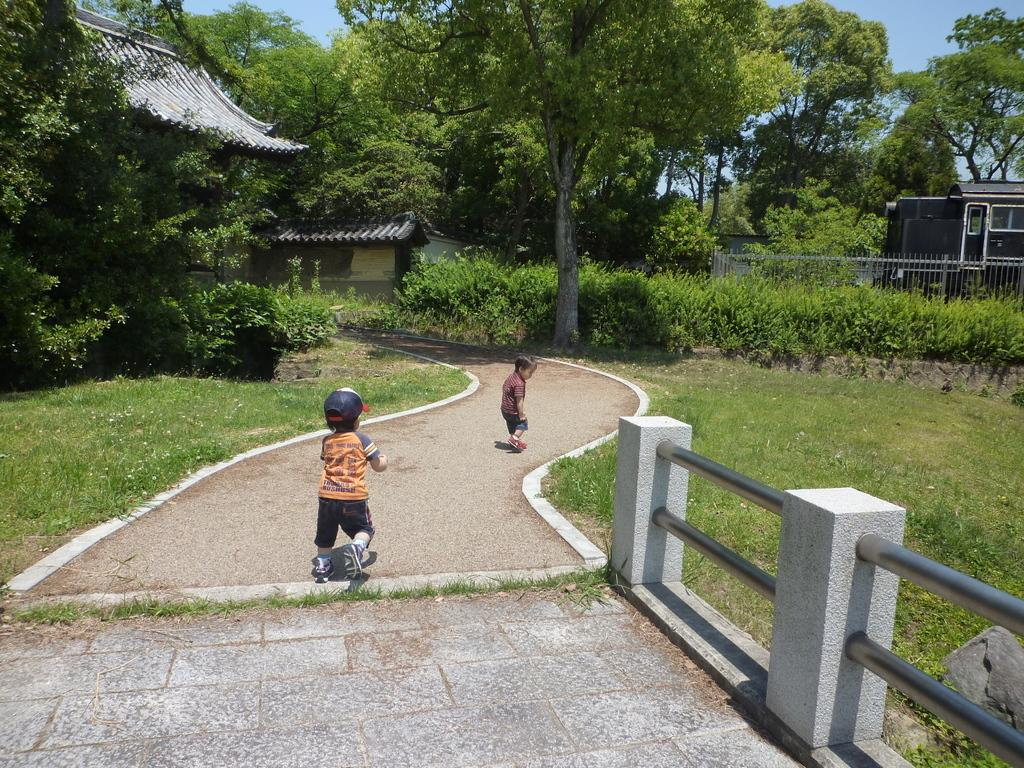How many kids are in the image? There are two kids in the image. What type of surface are the kids standing on? There is grass in the image, which is likely the surface they are standing on. What is the purpose of the fence in the image? The purpose of the fence is not explicitly stated, but it may be used to define boundaries or provide safety. What can be seen in the background of the image? In the background of the image, there are plants, trees, houses, and the sky. What type of fact can be seen on the ground in the image? There is no fact visible on the ground in the image; it is a scene featuring kids, grass, a fence, and background elements. 